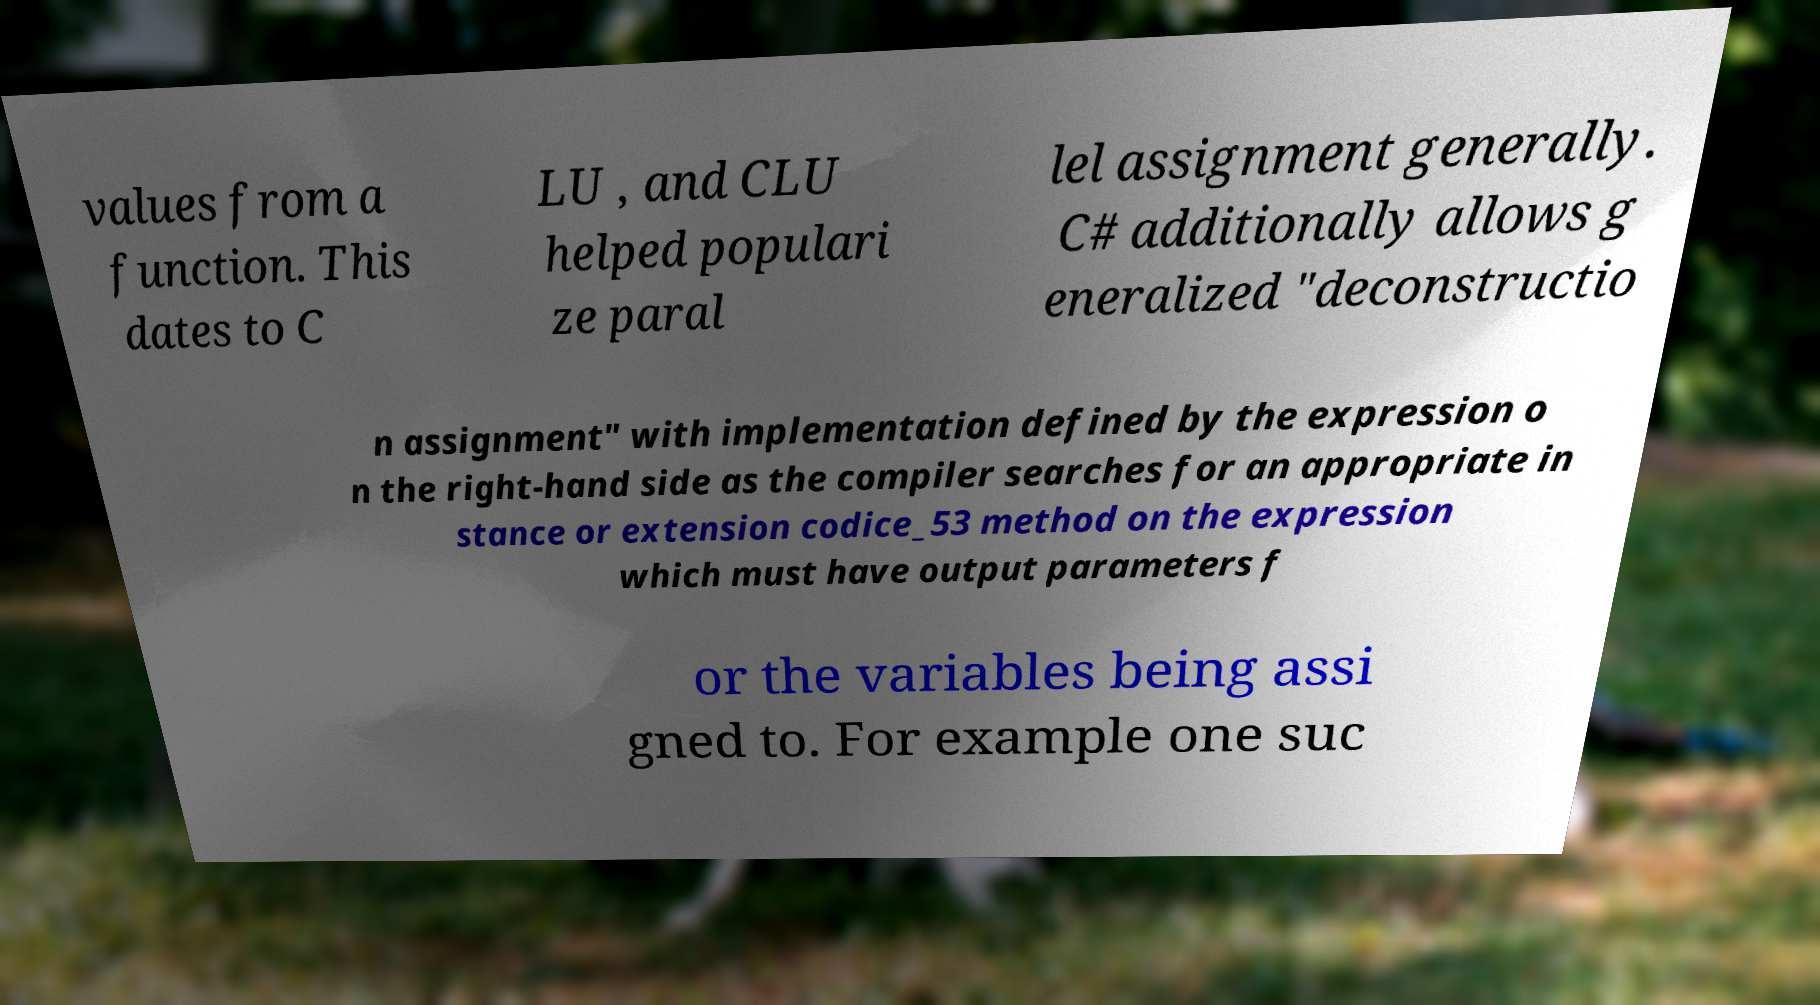What messages or text are displayed in this image? I need them in a readable, typed format. values from a function. This dates to C LU , and CLU helped populari ze paral lel assignment generally. C# additionally allows g eneralized "deconstructio n assignment" with implementation defined by the expression o n the right-hand side as the compiler searches for an appropriate in stance or extension codice_53 method on the expression which must have output parameters f or the variables being assi gned to. For example one suc 